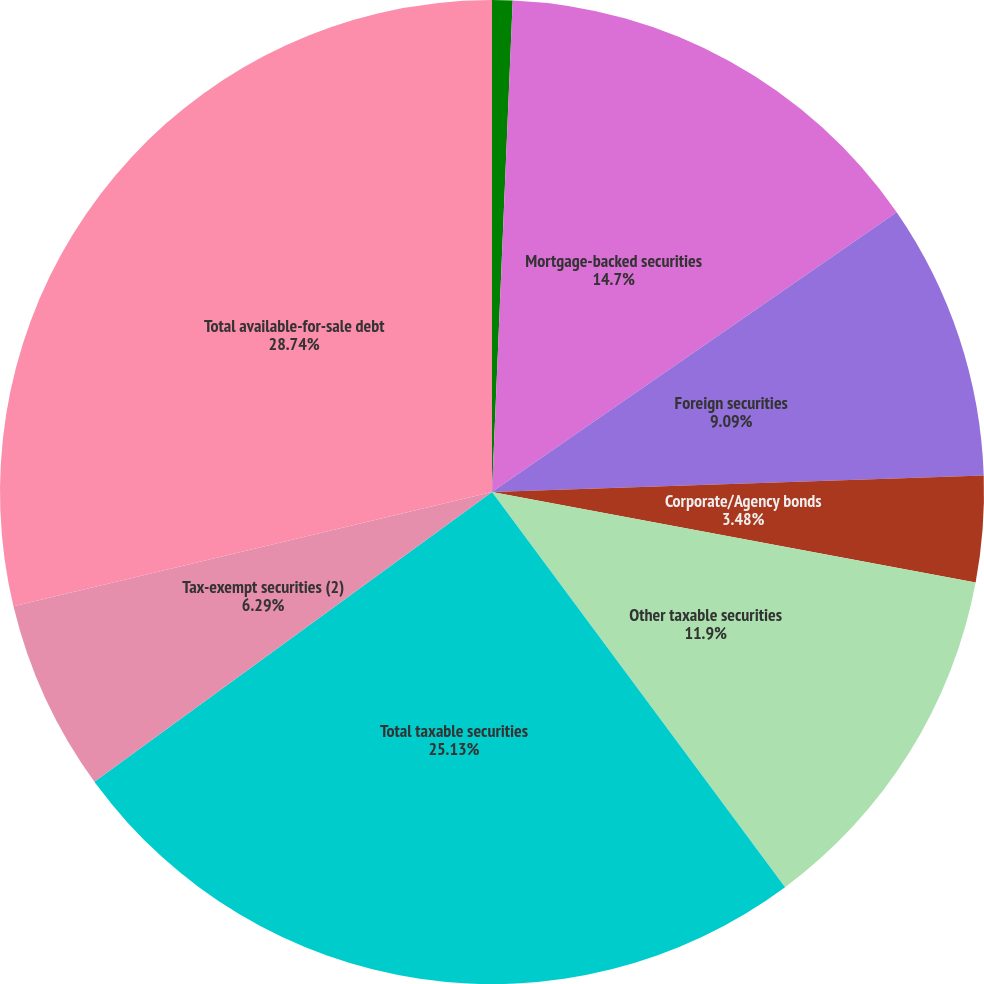Convert chart. <chart><loc_0><loc_0><loc_500><loc_500><pie_chart><fcel>US Treasury securities and<fcel>Mortgage-backed securities<fcel>Foreign securities<fcel>Corporate/Agency bonds<fcel>Other taxable securities<fcel>Total taxable securities<fcel>Tax-exempt securities (2)<fcel>Total available-for-sale debt<nl><fcel>0.67%<fcel>14.7%<fcel>9.09%<fcel>3.48%<fcel>11.9%<fcel>25.13%<fcel>6.29%<fcel>28.73%<nl></chart> 